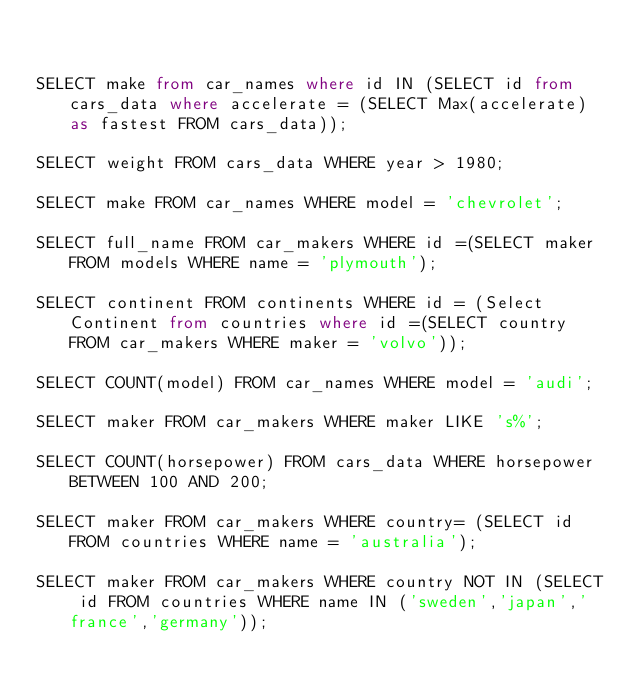Convert code to text. <code><loc_0><loc_0><loc_500><loc_500><_SQL_>

SELECT make from car_names where id IN (SELECT id from cars_data where accelerate = (SELECT Max(accelerate) as fastest FROM cars_data));

SELECT weight FROM cars_data WHERE year > 1980;

SELECT make FROM car_names WHERE model = 'chevrolet';

SELECT full_name FROM car_makers WHERE id =(SELECT maker FROM models WHERE name = 'plymouth');

SELECT continent FROM continents WHERE id = (Select Continent from countries where id =(SELECT country FROM car_makers WHERE maker = 'volvo'));

SELECT COUNT(model) FROM car_names WHERE model = 'audi';

SELECT maker FROM car_makers WHERE maker LIKE 's%';

SELECT COUNT(horsepower) FROM cars_data WHERE horsepower BETWEEN 100 AND 200;

SELECT maker FROM car_makers WHERE country= (SELECT id FROM countries WHERE name = 'australia');

SELECT maker FROM car_makers WHERE country NOT IN (SELECT id FROM countries WHERE name IN ('sweden','japan','france','germany'));</code> 